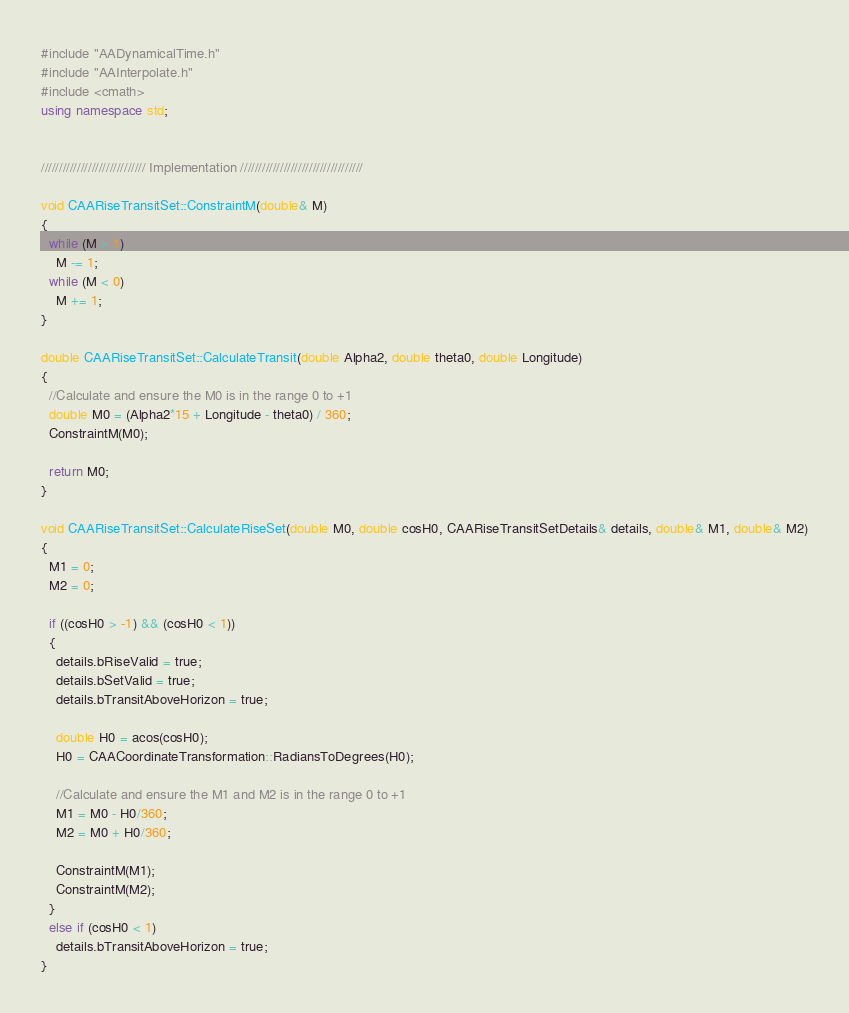Convert code to text. <code><loc_0><loc_0><loc_500><loc_500><_C++_>#include "AADynamicalTime.h"
#include "AAInterpolate.h"
#include <cmath>
using namespace std;


///////////////////////////// Implementation //////////////////////////////////

void CAARiseTransitSet::ConstraintM(double& M)
{
  while (M > 1)
    M -= 1;
  while (M < 0)
    M += 1;
}

double CAARiseTransitSet::CalculateTransit(double Alpha2, double theta0, double Longitude)
{
  //Calculate and ensure the M0 is in the range 0 to +1
  double M0 = (Alpha2*15 + Longitude - theta0) / 360; 
  ConstraintM(M0);

  return M0;
}

void CAARiseTransitSet::CalculateRiseSet(double M0, double cosH0, CAARiseTransitSetDetails& details, double& M1, double& M2)
{
  M1 = 0;
  M2 = 0;

  if ((cosH0 > -1) && (cosH0 < 1))
  {
    details.bRiseValid = true;
    details.bSetValid = true;
    details.bTransitAboveHorizon = true;

    double H0 = acos(cosH0);
    H0 = CAACoordinateTransformation::RadiansToDegrees(H0);

    //Calculate and ensure the M1 and M2 is in the range 0 to +1
    M1 = M0 - H0/360;
    M2 = M0 + H0/360;

    ConstraintM(M1);
    ConstraintM(M2);
  }
  else if (cosH0 < 1)
    details.bTransitAboveHorizon = true;
}</code> 